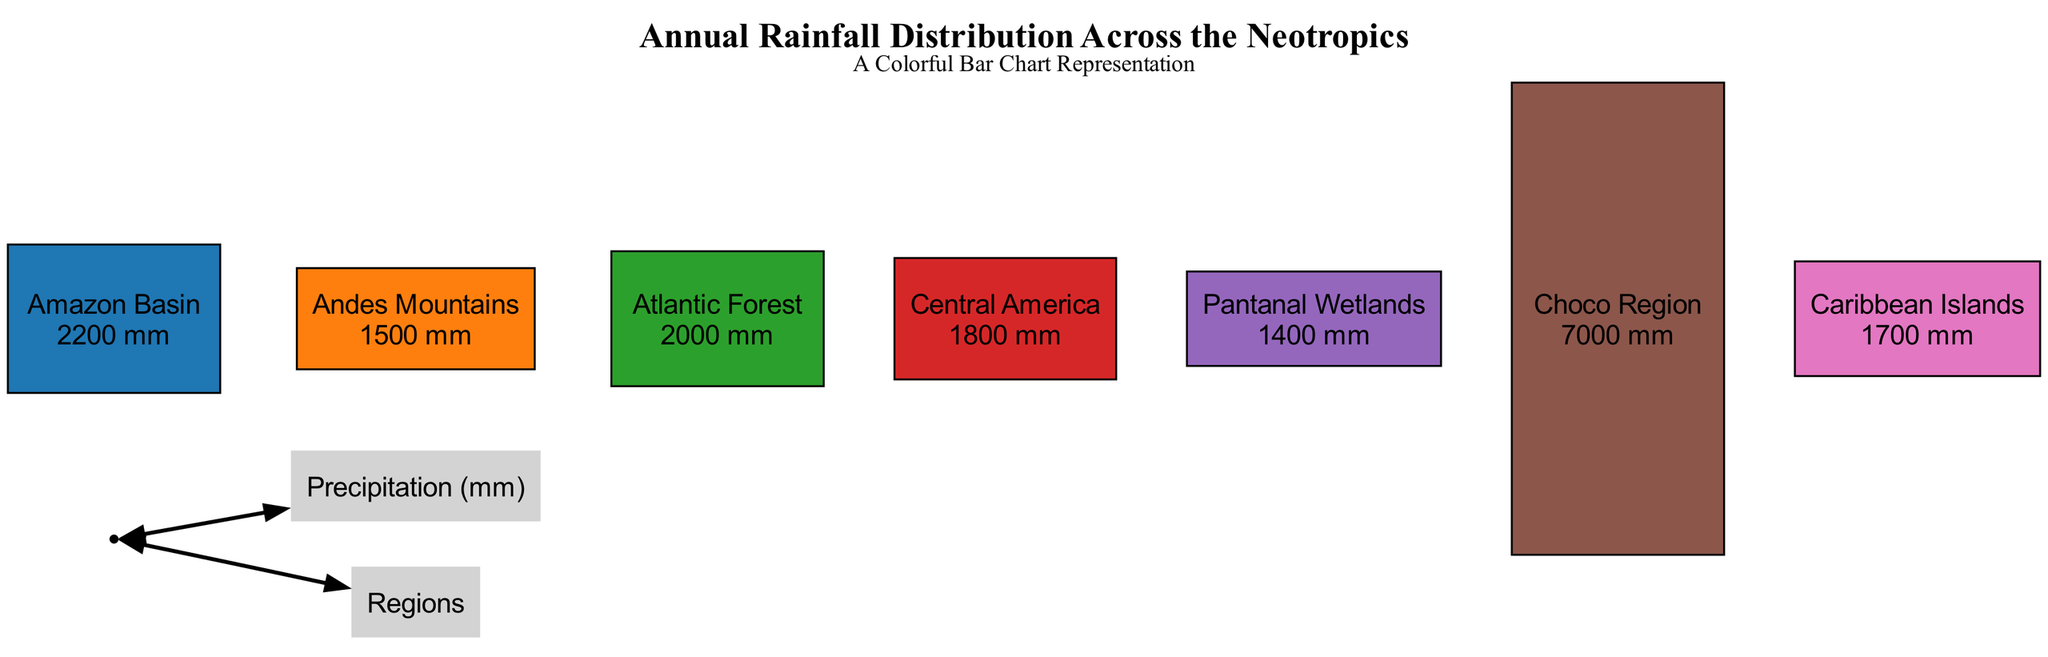What is the annual rainfall in the Amazon Basin? The diagram shows the rainfall level for each region. For the Amazon Basin, it is indicated as 2200 mm.
Answer: 2200 mm Which region has the highest annual rainfall? By comparing the rainfall amounts listed for each region in the diagram, the Choco Region has the highest annual rainfall at 7000 mm.
Answer: Choco Region How many regions are represented in the diagram? The diagram includes a total of 7 regions, which can be counted from the list provided.
Answer: 7 What is the annual rainfall in the Pantanal Wetlands? The diagram specifies the Pantanal Wetlands' annual rainfall to be 1400 mm, which can be found by observing the respective bar height or label.
Answer: 1400 mm Which two regions have annual rainfall levels less than 1800 mm? By examining the annual rainfall data for each region, we find that the Andes Mountains (1500 mm) and Pantanal Wetlands (1400 mm) are the only two that fall below 1800 mm.
Answer: Andes Mountains, Pantanal Wetlands What color represents the Atlantic Forest? The diagram assigns a specific color to each region, and the Atlantic Forest is represented in the color green (#2ca02c).
Answer: Green How does the annual rainfall of Central America compare to that of the Caribbean Islands? The diagram indicates that Central America receives 1800 mm and the Caribbean Islands receive 1700 mm, showing that Central America has more rainfall.
Answer: Central America has more rainfall What is the total annual rainfall (in mm) across all regions in the diagram? To find the total, we would add each region's annual rainfall values together: 2200 + 1500 + 2000 + 1800 + 1400 + 7000 + 1700 = 18600 mm total.
Answer: 18600 mm Which region has the lowest annual rainfall? From the data provided in the diagram, the Pantanal Wetlands have the lowest annual rainfall with 1400 mm.
Answer: Pantanal Wetlands 